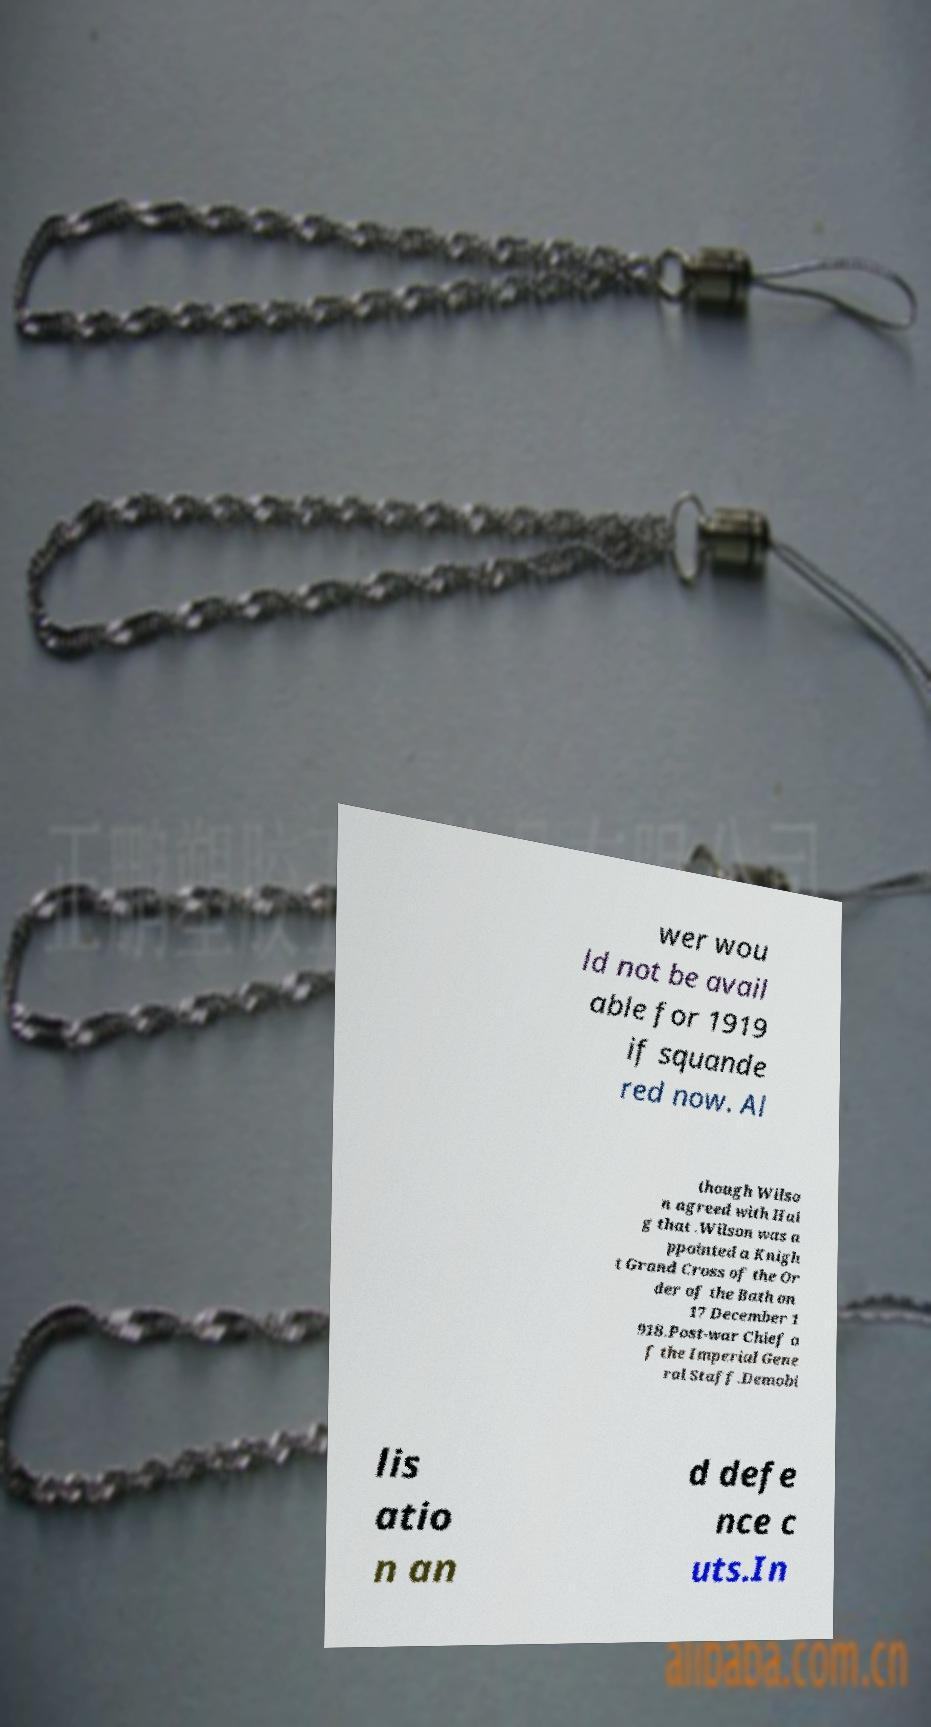What messages or text are displayed in this image? I need them in a readable, typed format. wer wou ld not be avail able for 1919 if squande red now. Al though Wilso n agreed with Hai g that .Wilson was a ppointed a Knigh t Grand Cross of the Or der of the Bath on 17 December 1 918.Post-war Chief o f the Imperial Gene ral Staff.Demobi lis atio n an d defe nce c uts.In 